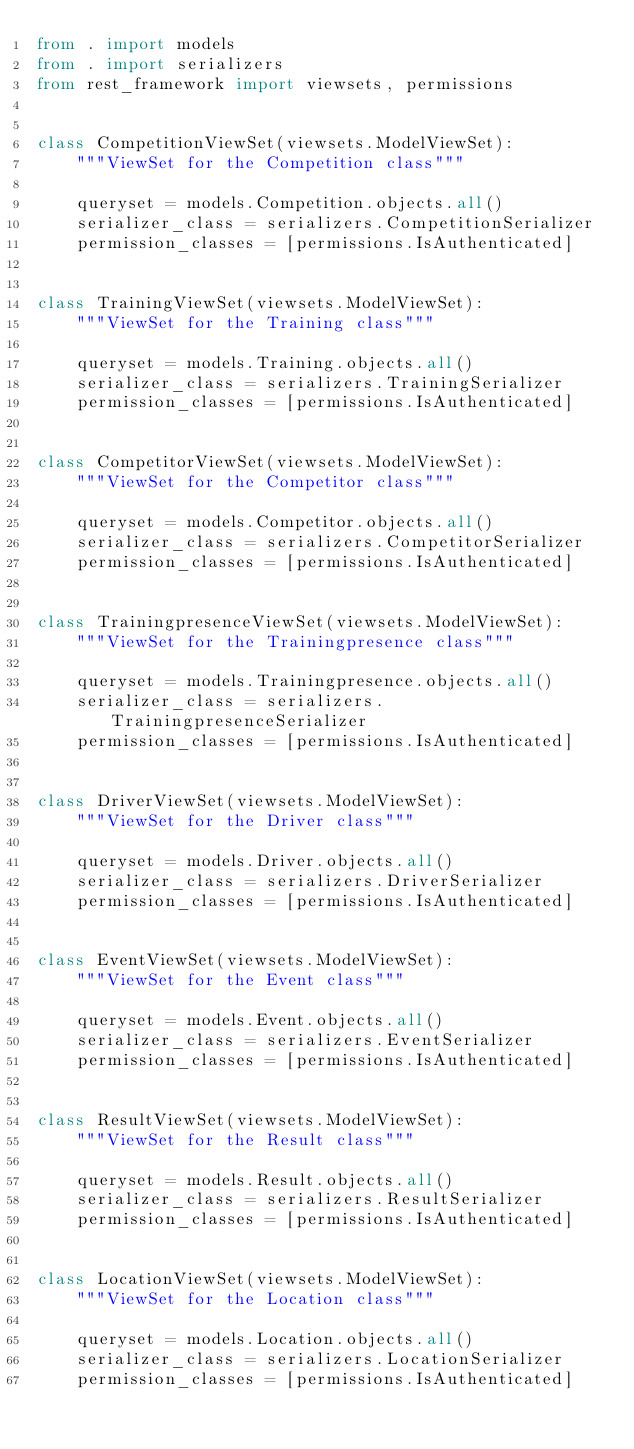<code> <loc_0><loc_0><loc_500><loc_500><_Python_>from . import models
from . import serializers
from rest_framework import viewsets, permissions


class CompetitionViewSet(viewsets.ModelViewSet):
    """ViewSet for the Competition class"""

    queryset = models.Competition.objects.all()
    serializer_class = serializers.CompetitionSerializer
    permission_classes = [permissions.IsAuthenticated]


class TrainingViewSet(viewsets.ModelViewSet):
    """ViewSet for the Training class"""

    queryset = models.Training.objects.all()
    serializer_class = serializers.TrainingSerializer
    permission_classes = [permissions.IsAuthenticated]


class CompetitorViewSet(viewsets.ModelViewSet):
    """ViewSet for the Competitor class"""

    queryset = models.Competitor.objects.all()
    serializer_class = serializers.CompetitorSerializer
    permission_classes = [permissions.IsAuthenticated]


class TrainingpresenceViewSet(viewsets.ModelViewSet):
    """ViewSet for the Trainingpresence class"""

    queryset = models.Trainingpresence.objects.all()
    serializer_class = serializers.TrainingpresenceSerializer
    permission_classes = [permissions.IsAuthenticated]


class DriverViewSet(viewsets.ModelViewSet):
    """ViewSet for the Driver class"""

    queryset = models.Driver.objects.all()
    serializer_class = serializers.DriverSerializer
    permission_classes = [permissions.IsAuthenticated]


class EventViewSet(viewsets.ModelViewSet):
    """ViewSet for the Event class"""

    queryset = models.Event.objects.all()
    serializer_class = serializers.EventSerializer
    permission_classes = [permissions.IsAuthenticated]


class ResultViewSet(viewsets.ModelViewSet):
    """ViewSet for the Result class"""

    queryset = models.Result.objects.all()
    serializer_class = serializers.ResultSerializer
    permission_classes = [permissions.IsAuthenticated]


class LocationViewSet(viewsets.ModelViewSet):
    """ViewSet for the Location class"""

    queryset = models.Location.objects.all()
    serializer_class = serializers.LocationSerializer
    permission_classes = [permissions.IsAuthenticated]


</code> 